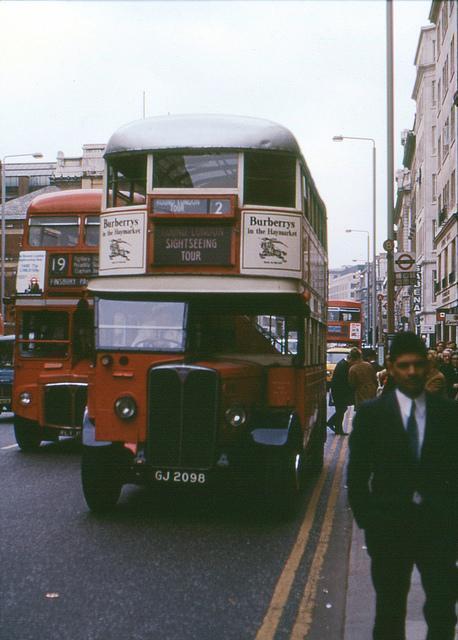Which country were we probably likely to see these old double decker buses?
Indicate the correct response by choosing from the four available options to answer the question.
Options: Germany, france, uk, usa. Uk. 